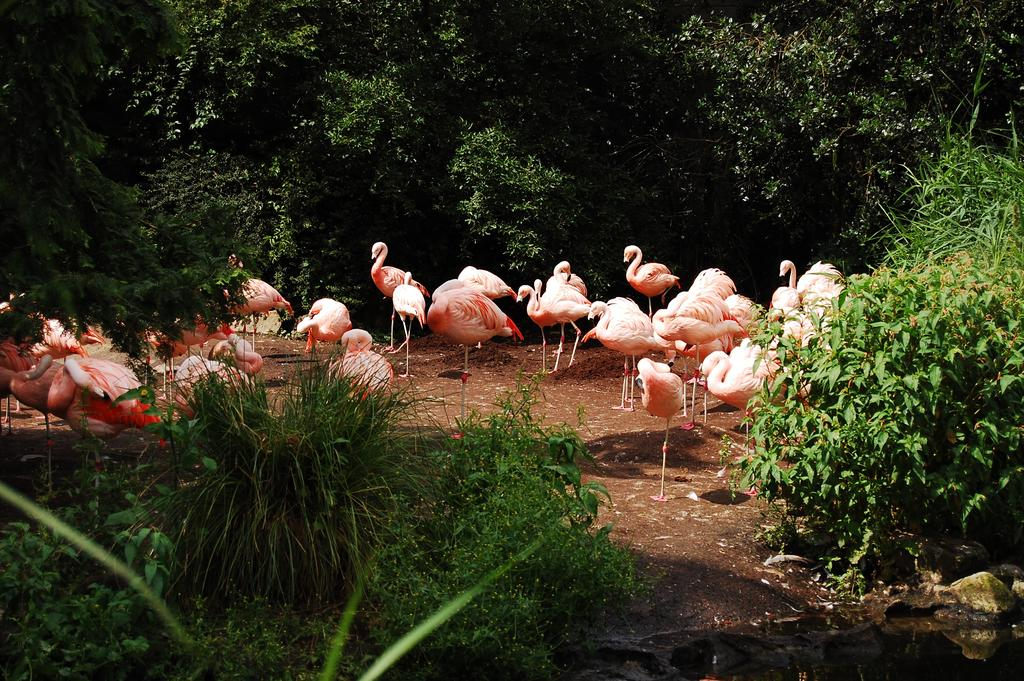What animals are present in the image? There are many swans in the image. What can be seen in the background of the image? There are trees in the background of the image. What is the primary setting of the image? There is water visible in the image. What type of clothing is at the bottom of the image? There are pants at the bottom of the image. What type of milk is being poured into the blade in the image? There is no milk or blade present in the image; it features swans in a water setting with trees in the background and pants at the bottom. 